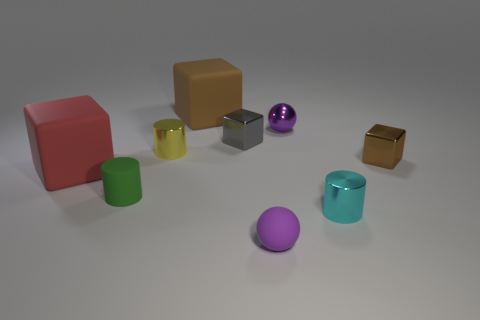What can you infer about the light source in the image? Based on the shadows and highlights present, it seems that the light source is positioned above and slightly to the right of the scene. The shadows are cast towards the left, suggesting that the light is directional and not diffused evenly throughout the scene. 